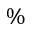Convert formula to latex. <formula><loc_0><loc_0><loc_500><loc_500>\%</formula> 